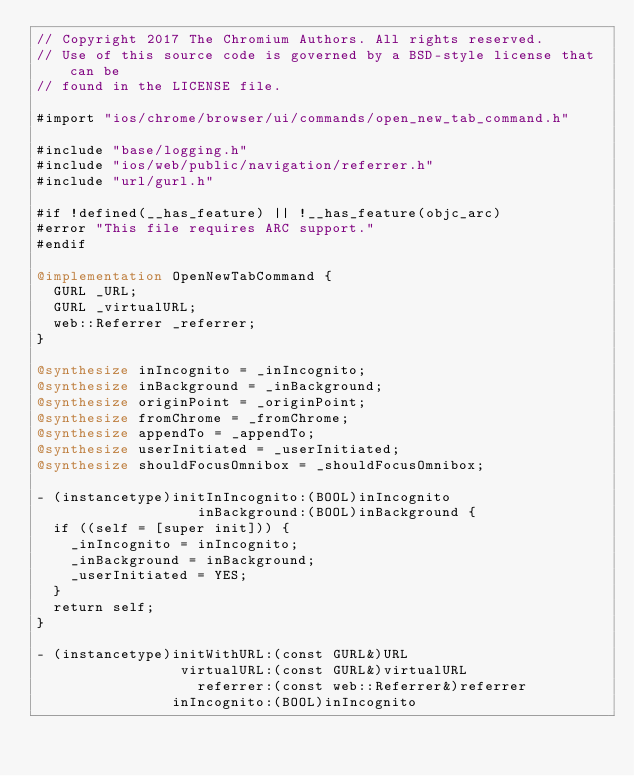<code> <loc_0><loc_0><loc_500><loc_500><_ObjectiveC_>// Copyright 2017 The Chromium Authors. All rights reserved.
// Use of this source code is governed by a BSD-style license that can be
// found in the LICENSE file.

#import "ios/chrome/browser/ui/commands/open_new_tab_command.h"

#include "base/logging.h"
#include "ios/web/public/navigation/referrer.h"
#include "url/gurl.h"

#if !defined(__has_feature) || !__has_feature(objc_arc)
#error "This file requires ARC support."
#endif

@implementation OpenNewTabCommand {
  GURL _URL;
  GURL _virtualURL;
  web::Referrer _referrer;
}

@synthesize inIncognito = _inIncognito;
@synthesize inBackground = _inBackground;
@synthesize originPoint = _originPoint;
@synthesize fromChrome = _fromChrome;
@synthesize appendTo = _appendTo;
@synthesize userInitiated = _userInitiated;
@synthesize shouldFocusOmnibox = _shouldFocusOmnibox;

- (instancetype)initInIncognito:(BOOL)inIncognito
                   inBackground:(BOOL)inBackground {
  if ((self = [super init])) {
    _inIncognito = inIncognito;
    _inBackground = inBackground;
    _userInitiated = YES;
  }
  return self;
}

- (instancetype)initWithURL:(const GURL&)URL
                 virtualURL:(const GURL&)virtualURL
                   referrer:(const web::Referrer&)referrer
                inIncognito:(BOOL)inIncognito</code> 